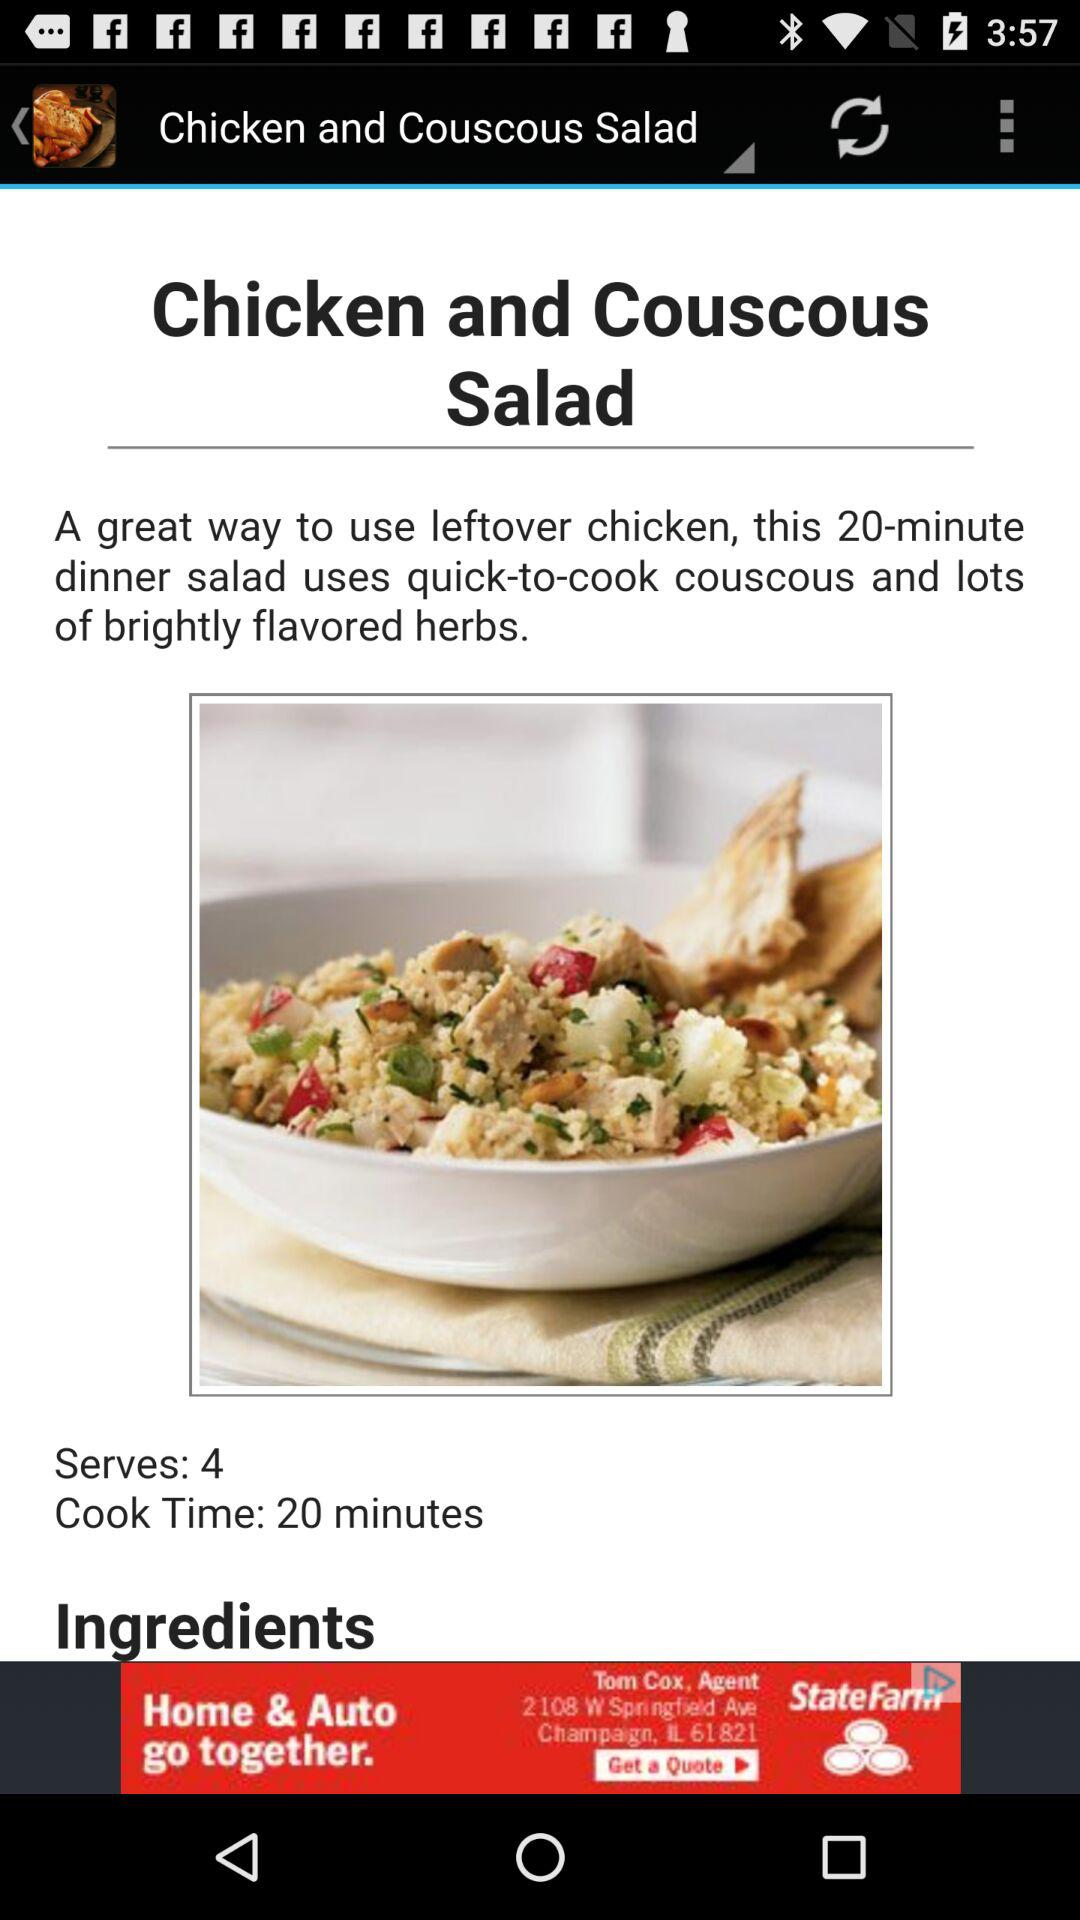How many serves are there? There are 4 serves. 